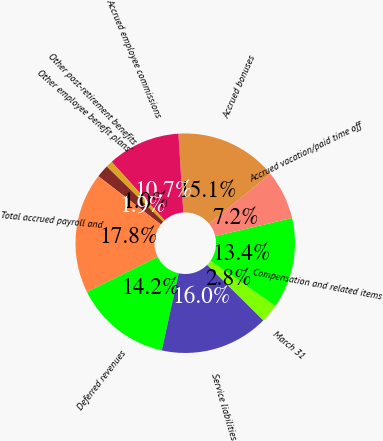Convert chart to OTSL. <chart><loc_0><loc_0><loc_500><loc_500><pie_chart><fcel>March 31<fcel>Compensation and related items<fcel>Accrued vacation/paid time off<fcel>Accrued bonuses<fcel>Accrued employee commissions<fcel>Other post-retirement benefits<fcel>Other employee benefit plans'<fcel>Total accrued payroll and<fcel>Deferred revenues<fcel>Service liabilities<nl><fcel>2.75%<fcel>13.36%<fcel>7.17%<fcel>15.13%<fcel>10.71%<fcel>0.98%<fcel>1.86%<fcel>17.78%<fcel>14.24%<fcel>16.01%<nl></chart> 